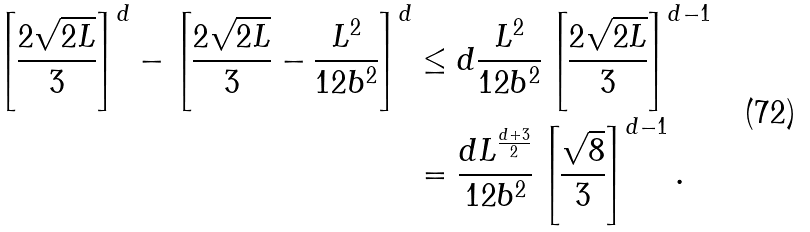<formula> <loc_0><loc_0><loc_500><loc_500>\left [ \frac { 2 \sqrt { 2 L } } { 3 } \right ] ^ { d } - \left [ \frac { 2 \sqrt { 2 L } } { 3 } - \frac { L ^ { 2 } } { 1 2 b ^ { 2 } } \right ] ^ { d } & \leq d \frac { L ^ { 2 } } { 1 2 b ^ { 2 } } \left [ \frac { 2 \sqrt { 2 L } } { 3 } \right ] ^ { d - 1 } \\ & = \frac { d L ^ { \frac { d + 3 } { 2 } } } { 1 2 b ^ { 2 } } \left [ \frac { \sqrt { 8 } } { 3 } \right ] ^ { d - 1 } .</formula> 